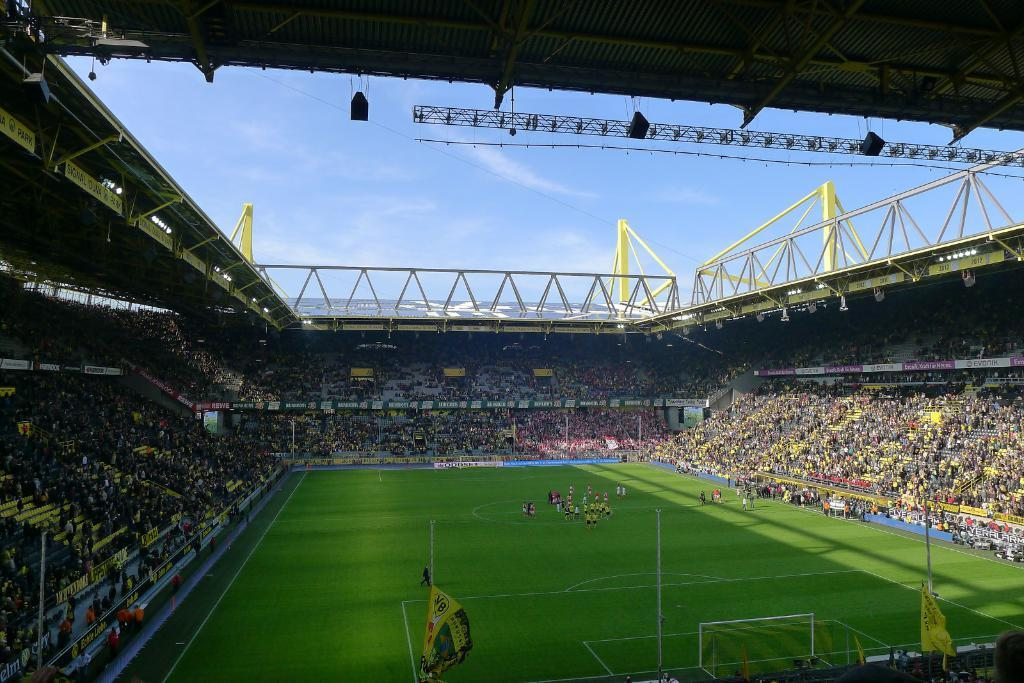What type of structure is shown in the image? There is a stadium in the image. Can you describe the scene inside the stadium? There are many people inside the stadium, and there are players on the ground. What can be seen above the people and players? There is a ceiling visible in the image. What is visible outside the stadium? The sky is visible in the image. What type of account does the grandfather have in the image? There is no mention of a grandfather or an account in the image. 